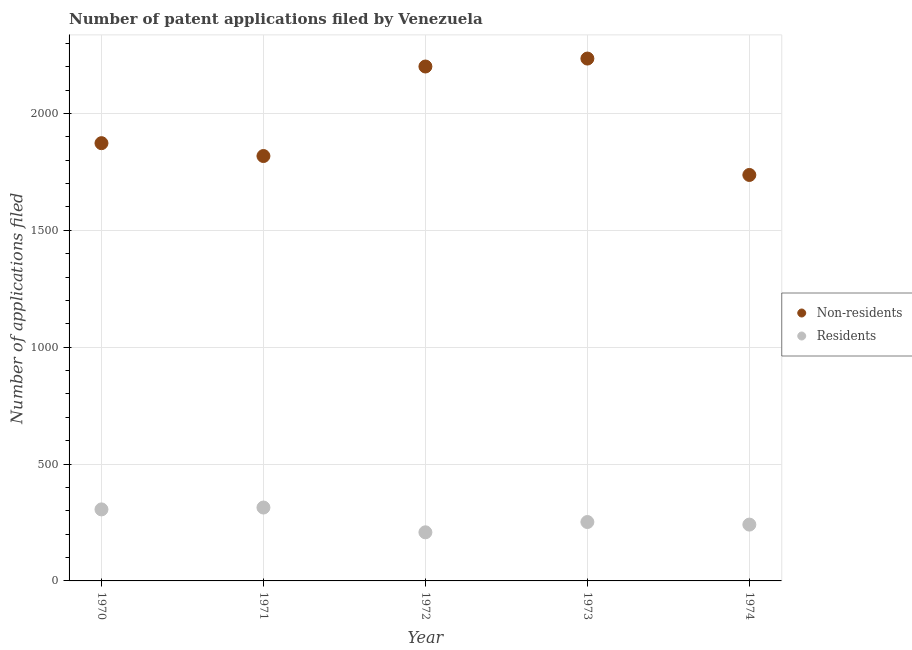What is the number of patent applications by non residents in 1973?
Provide a succinct answer. 2235. Across all years, what is the maximum number of patent applications by non residents?
Keep it short and to the point. 2235. Across all years, what is the minimum number of patent applications by residents?
Your answer should be compact. 208. In which year was the number of patent applications by residents maximum?
Keep it short and to the point. 1971. In which year was the number of patent applications by non residents minimum?
Keep it short and to the point. 1974. What is the total number of patent applications by non residents in the graph?
Offer a terse response. 9864. What is the difference between the number of patent applications by non residents in 1970 and that in 1973?
Provide a short and direct response. -362. What is the average number of patent applications by non residents per year?
Your answer should be compact. 1972.8. In the year 1974, what is the difference between the number of patent applications by residents and number of patent applications by non residents?
Offer a very short reply. -1496. What is the ratio of the number of patent applications by non residents in 1971 to that in 1974?
Keep it short and to the point. 1.05. What is the difference between the highest and the second highest number of patent applications by residents?
Give a very brief answer. 8. What is the difference between the highest and the lowest number of patent applications by residents?
Offer a terse response. 106. In how many years, is the number of patent applications by non residents greater than the average number of patent applications by non residents taken over all years?
Offer a terse response. 2. Is the sum of the number of patent applications by non residents in 1971 and 1974 greater than the maximum number of patent applications by residents across all years?
Ensure brevity in your answer.  Yes. Is the number of patent applications by residents strictly less than the number of patent applications by non residents over the years?
Your answer should be very brief. Yes. How many years are there in the graph?
Ensure brevity in your answer.  5. Are the values on the major ticks of Y-axis written in scientific E-notation?
Your answer should be compact. No. Does the graph contain any zero values?
Offer a terse response. No. Does the graph contain grids?
Ensure brevity in your answer.  Yes. Where does the legend appear in the graph?
Make the answer very short. Center right. What is the title of the graph?
Make the answer very short. Number of patent applications filed by Venezuela. Does "Official aid received" appear as one of the legend labels in the graph?
Your response must be concise. No. What is the label or title of the Y-axis?
Provide a short and direct response. Number of applications filed. What is the Number of applications filed in Non-residents in 1970?
Provide a succinct answer. 1873. What is the Number of applications filed in Residents in 1970?
Your answer should be very brief. 306. What is the Number of applications filed in Non-residents in 1971?
Provide a short and direct response. 1818. What is the Number of applications filed in Residents in 1971?
Give a very brief answer. 314. What is the Number of applications filed of Non-residents in 1972?
Give a very brief answer. 2201. What is the Number of applications filed in Residents in 1972?
Give a very brief answer. 208. What is the Number of applications filed of Non-residents in 1973?
Provide a short and direct response. 2235. What is the Number of applications filed of Residents in 1973?
Give a very brief answer. 252. What is the Number of applications filed of Non-residents in 1974?
Keep it short and to the point. 1737. What is the Number of applications filed in Residents in 1974?
Provide a succinct answer. 241. Across all years, what is the maximum Number of applications filed of Non-residents?
Your answer should be compact. 2235. Across all years, what is the maximum Number of applications filed of Residents?
Give a very brief answer. 314. Across all years, what is the minimum Number of applications filed of Non-residents?
Provide a succinct answer. 1737. Across all years, what is the minimum Number of applications filed of Residents?
Your answer should be compact. 208. What is the total Number of applications filed of Non-residents in the graph?
Ensure brevity in your answer.  9864. What is the total Number of applications filed of Residents in the graph?
Your response must be concise. 1321. What is the difference between the Number of applications filed in Non-residents in 1970 and that in 1971?
Provide a succinct answer. 55. What is the difference between the Number of applications filed in Non-residents in 1970 and that in 1972?
Make the answer very short. -328. What is the difference between the Number of applications filed in Residents in 1970 and that in 1972?
Provide a succinct answer. 98. What is the difference between the Number of applications filed of Non-residents in 1970 and that in 1973?
Offer a terse response. -362. What is the difference between the Number of applications filed of Non-residents in 1970 and that in 1974?
Keep it short and to the point. 136. What is the difference between the Number of applications filed in Non-residents in 1971 and that in 1972?
Give a very brief answer. -383. What is the difference between the Number of applications filed of Residents in 1971 and that in 1972?
Offer a very short reply. 106. What is the difference between the Number of applications filed of Non-residents in 1971 and that in 1973?
Give a very brief answer. -417. What is the difference between the Number of applications filed in Residents in 1971 and that in 1973?
Offer a very short reply. 62. What is the difference between the Number of applications filed of Non-residents in 1972 and that in 1973?
Keep it short and to the point. -34. What is the difference between the Number of applications filed in Residents in 1972 and that in 1973?
Provide a short and direct response. -44. What is the difference between the Number of applications filed of Non-residents in 1972 and that in 1974?
Offer a terse response. 464. What is the difference between the Number of applications filed in Residents in 1972 and that in 1974?
Your answer should be compact. -33. What is the difference between the Number of applications filed in Non-residents in 1973 and that in 1974?
Ensure brevity in your answer.  498. What is the difference between the Number of applications filed of Residents in 1973 and that in 1974?
Your answer should be compact. 11. What is the difference between the Number of applications filed of Non-residents in 1970 and the Number of applications filed of Residents in 1971?
Your answer should be compact. 1559. What is the difference between the Number of applications filed in Non-residents in 1970 and the Number of applications filed in Residents in 1972?
Give a very brief answer. 1665. What is the difference between the Number of applications filed of Non-residents in 1970 and the Number of applications filed of Residents in 1973?
Give a very brief answer. 1621. What is the difference between the Number of applications filed in Non-residents in 1970 and the Number of applications filed in Residents in 1974?
Offer a terse response. 1632. What is the difference between the Number of applications filed of Non-residents in 1971 and the Number of applications filed of Residents in 1972?
Keep it short and to the point. 1610. What is the difference between the Number of applications filed of Non-residents in 1971 and the Number of applications filed of Residents in 1973?
Your answer should be compact. 1566. What is the difference between the Number of applications filed of Non-residents in 1971 and the Number of applications filed of Residents in 1974?
Give a very brief answer. 1577. What is the difference between the Number of applications filed of Non-residents in 1972 and the Number of applications filed of Residents in 1973?
Offer a terse response. 1949. What is the difference between the Number of applications filed of Non-residents in 1972 and the Number of applications filed of Residents in 1974?
Provide a short and direct response. 1960. What is the difference between the Number of applications filed of Non-residents in 1973 and the Number of applications filed of Residents in 1974?
Ensure brevity in your answer.  1994. What is the average Number of applications filed of Non-residents per year?
Your response must be concise. 1972.8. What is the average Number of applications filed in Residents per year?
Your response must be concise. 264.2. In the year 1970, what is the difference between the Number of applications filed in Non-residents and Number of applications filed in Residents?
Your answer should be compact. 1567. In the year 1971, what is the difference between the Number of applications filed in Non-residents and Number of applications filed in Residents?
Provide a short and direct response. 1504. In the year 1972, what is the difference between the Number of applications filed of Non-residents and Number of applications filed of Residents?
Offer a very short reply. 1993. In the year 1973, what is the difference between the Number of applications filed of Non-residents and Number of applications filed of Residents?
Offer a terse response. 1983. In the year 1974, what is the difference between the Number of applications filed of Non-residents and Number of applications filed of Residents?
Your answer should be compact. 1496. What is the ratio of the Number of applications filed of Non-residents in 1970 to that in 1971?
Make the answer very short. 1.03. What is the ratio of the Number of applications filed of Residents in 1970 to that in 1971?
Ensure brevity in your answer.  0.97. What is the ratio of the Number of applications filed of Non-residents in 1970 to that in 1972?
Offer a very short reply. 0.85. What is the ratio of the Number of applications filed in Residents in 1970 to that in 1972?
Your response must be concise. 1.47. What is the ratio of the Number of applications filed of Non-residents in 1970 to that in 1973?
Make the answer very short. 0.84. What is the ratio of the Number of applications filed of Residents in 1970 to that in 1973?
Offer a terse response. 1.21. What is the ratio of the Number of applications filed of Non-residents in 1970 to that in 1974?
Your response must be concise. 1.08. What is the ratio of the Number of applications filed of Residents in 1970 to that in 1974?
Ensure brevity in your answer.  1.27. What is the ratio of the Number of applications filed in Non-residents in 1971 to that in 1972?
Provide a succinct answer. 0.83. What is the ratio of the Number of applications filed of Residents in 1971 to that in 1972?
Ensure brevity in your answer.  1.51. What is the ratio of the Number of applications filed in Non-residents in 1971 to that in 1973?
Keep it short and to the point. 0.81. What is the ratio of the Number of applications filed of Residents in 1971 to that in 1973?
Keep it short and to the point. 1.25. What is the ratio of the Number of applications filed of Non-residents in 1971 to that in 1974?
Offer a terse response. 1.05. What is the ratio of the Number of applications filed in Residents in 1971 to that in 1974?
Ensure brevity in your answer.  1.3. What is the ratio of the Number of applications filed of Non-residents in 1972 to that in 1973?
Give a very brief answer. 0.98. What is the ratio of the Number of applications filed in Residents in 1972 to that in 1973?
Provide a succinct answer. 0.83. What is the ratio of the Number of applications filed in Non-residents in 1972 to that in 1974?
Keep it short and to the point. 1.27. What is the ratio of the Number of applications filed in Residents in 1972 to that in 1974?
Give a very brief answer. 0.86. What is the ratio of the Number of applications filed in Non-residents in 1973 to that in 1974?
Ensure brevity in your answer.  1.29. What is the ratio of the Number of applications filed in Residents in 1973 to that in 1974?
Keep it short and to the point. 1.05. What is the difference between the highest and the second highest Number of applications filed of Residents?
Offer a terse response. 8. What is the difference between the highest and the lowest Number of applications filed of Non-residents?
Ensure brevity in your answer.  498. What is the difference between the highest and the lowest Number of applications filed in Residents?
Your answer should be compact. 106. 